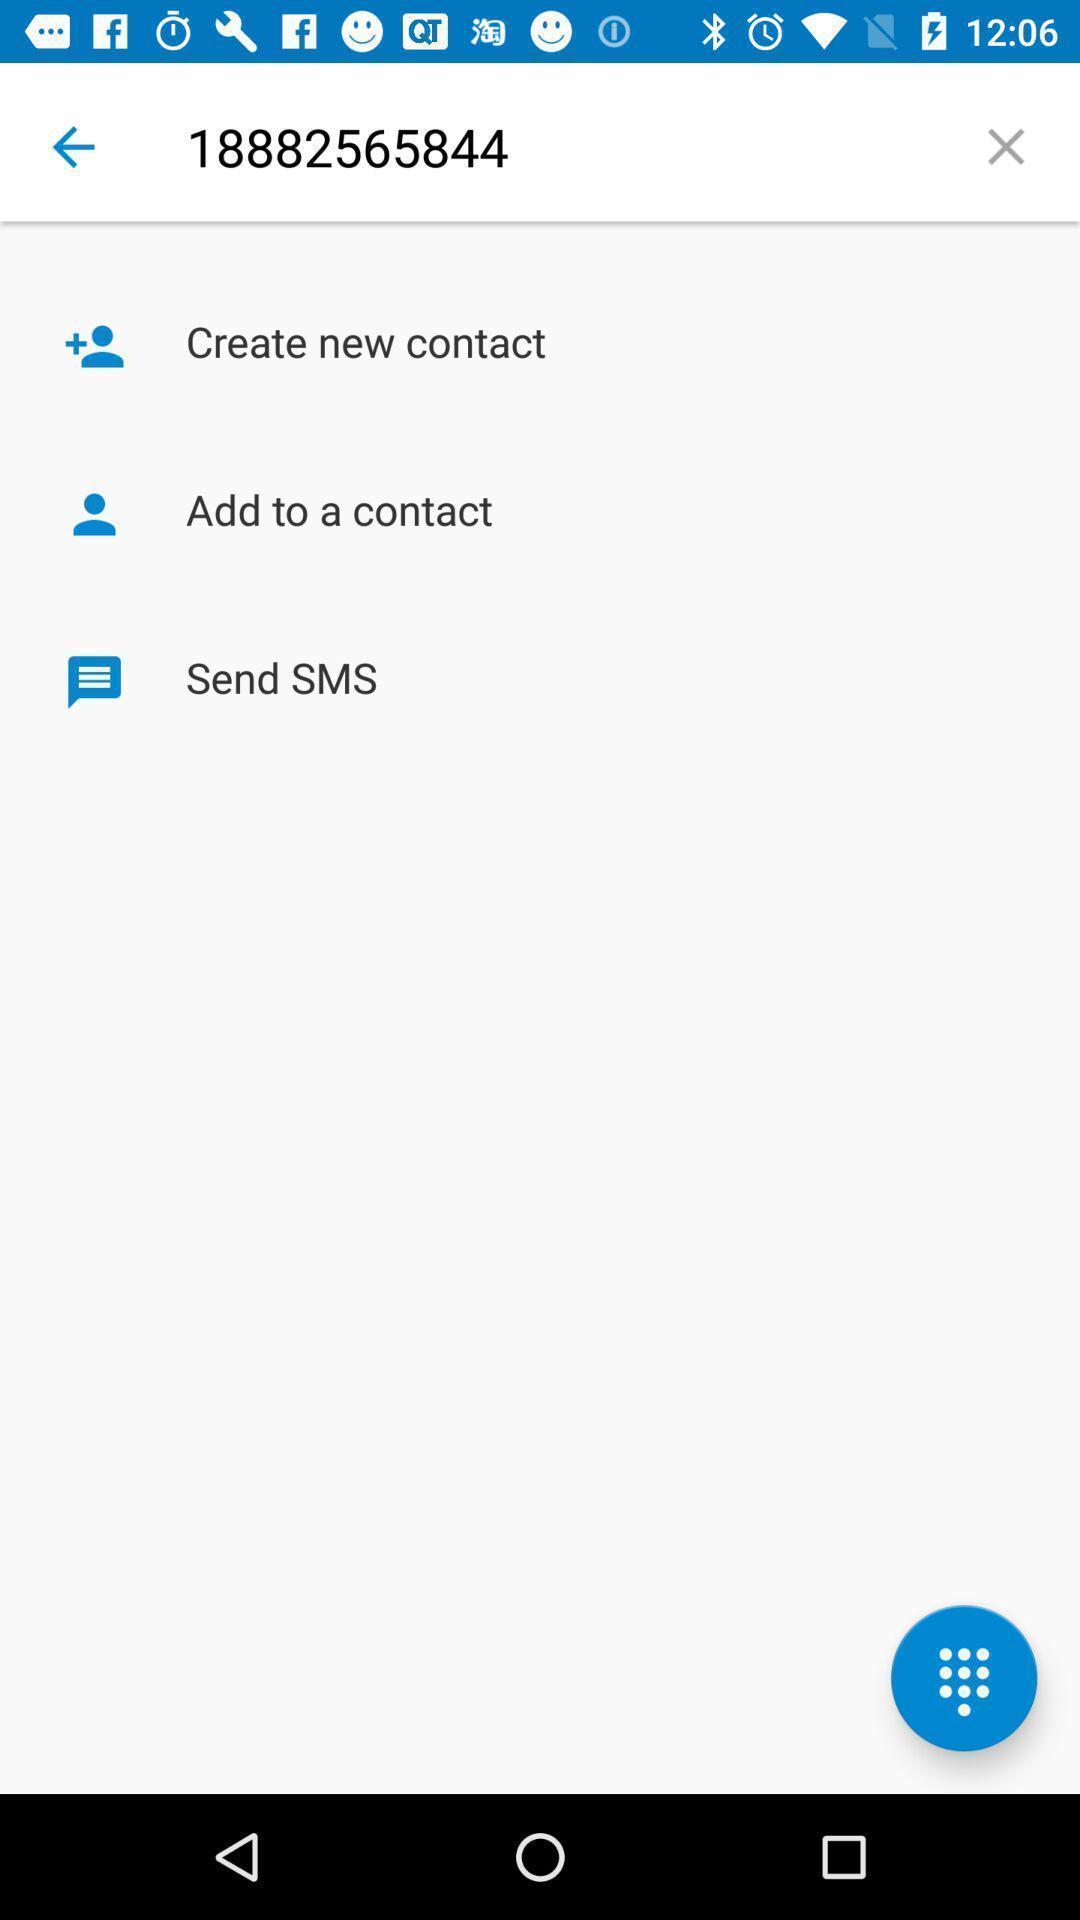Describe the visual elements of this screenshot. Page showing number with create new contact. 